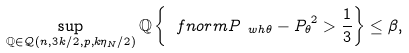<formula> <loc_0><loc_0><loc_500><loc_500>\sup _ { \mathbb { Q } \in \mathcal { Q } ( n , { 3 k } / { 2 } , p , k \eta _ { N } / 2 ) } \mathbb { Q } \left \{ \ f n o r m { P _ { \ w h { \theta } } - P _ { \theta } } ^ { 2 } > \frac { 1 } { 3 } \right \} \leq \beta ,</formula> 